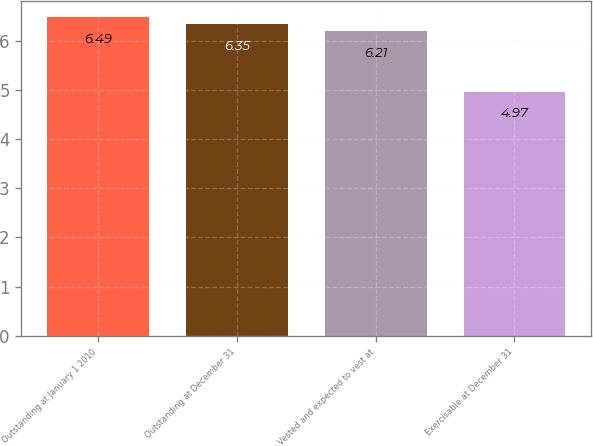Convert chart to OTSL. <chart><loc_0><loc_0><loc_500><loc_500><bar_chart><fcel>Outstanding at January 1 2010<fcel>Outstanding at December 31<fcel>Vested and expected to vest at<fcel>Exercisable at December 31<nl><fcel>6.49<fcel>6.35<fcel>6.21<fcel>4.97<nl></chart> 